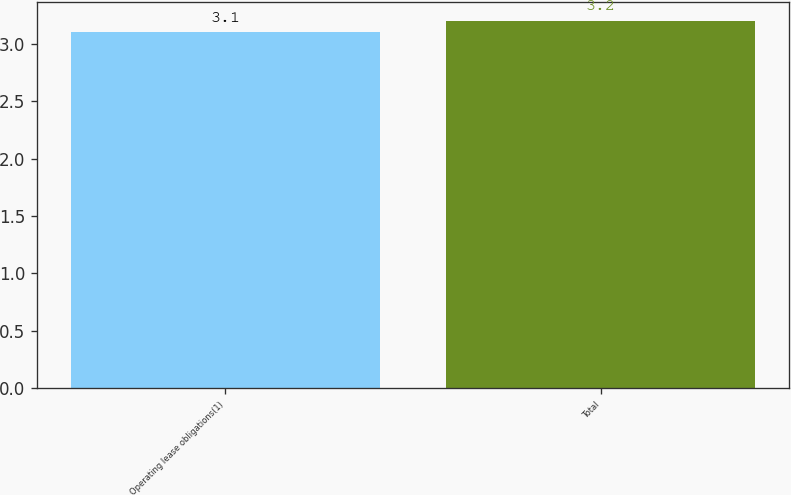Convert chart to OTSL. <chart><loc_0><loc_0><loc_500><loc_500><bar_chart><fcel>Operating lease obligations(1)<fcel>Total<nl><fcel>3.1<fcel>3.2<nl></chart> 